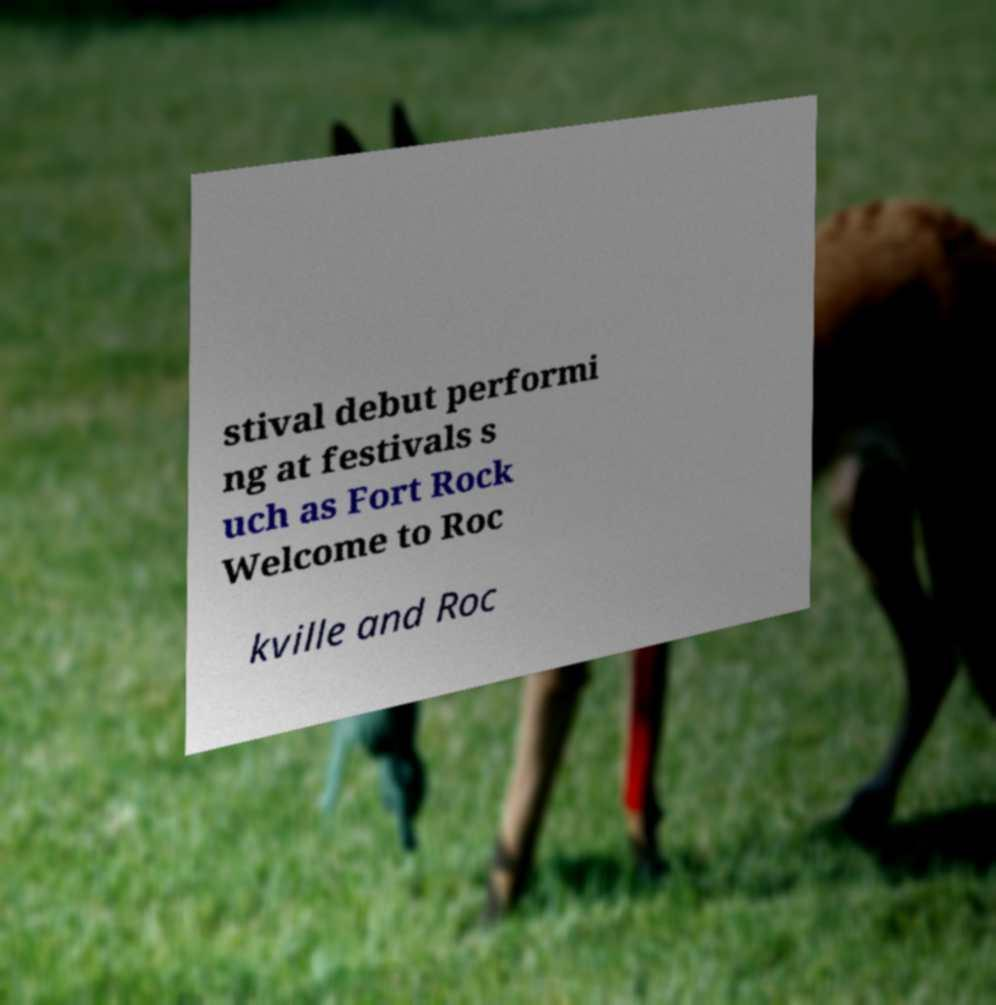Can you read and provide the text displayed in the image?This photo seems to have some interesting text. Can you extract and type it out for me? stival debut performi ng at festivals s uch as Fort Rock Welcome to Roc kville and Roc 